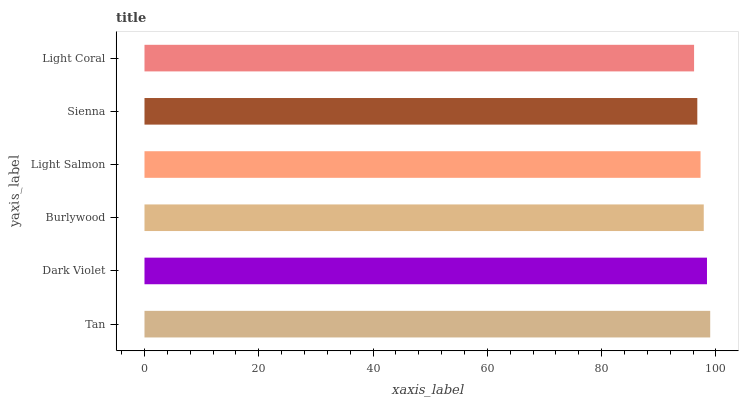Is Light Coral the minimum?
Answer yes or no. Yes. Is Tan the maximum?
Answer yes or no. Yes. Is Dark Violet the minimum?
Answer yes or no. No. Is Dark Violet the maximum?
Answer yes or no. No. Is Tan greater than Dark Violet?
Answer yes or no. Yes. Is Dark Violet less than Tan?
Answer yes or no. Yes. Is Dark Violet greater than Tan?
Answer yes or no. No. Is Tan less than Dark Violet?
Answer yes or no. No. Is Burlywood the high median?
Answer yes or no. Yes. Is Light Salmon the low median?
Answer yes or no. Yes. Is Light Coral the high median?
Answer yes or no. No. Is Tan the low median?
Answer yes or no. No. 